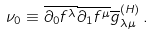<formula> <loc_0><loc_0><loc_500><loc_500>\nu _ { 0 } \equiv \overline { \partial _ { 0 } f ^ { \lambda } } \overline { \partial _ { 1 } f ^ { \mu } } \overline { g } _ { \lambda \mu } ^ { ( H ) } \, .</formula> 